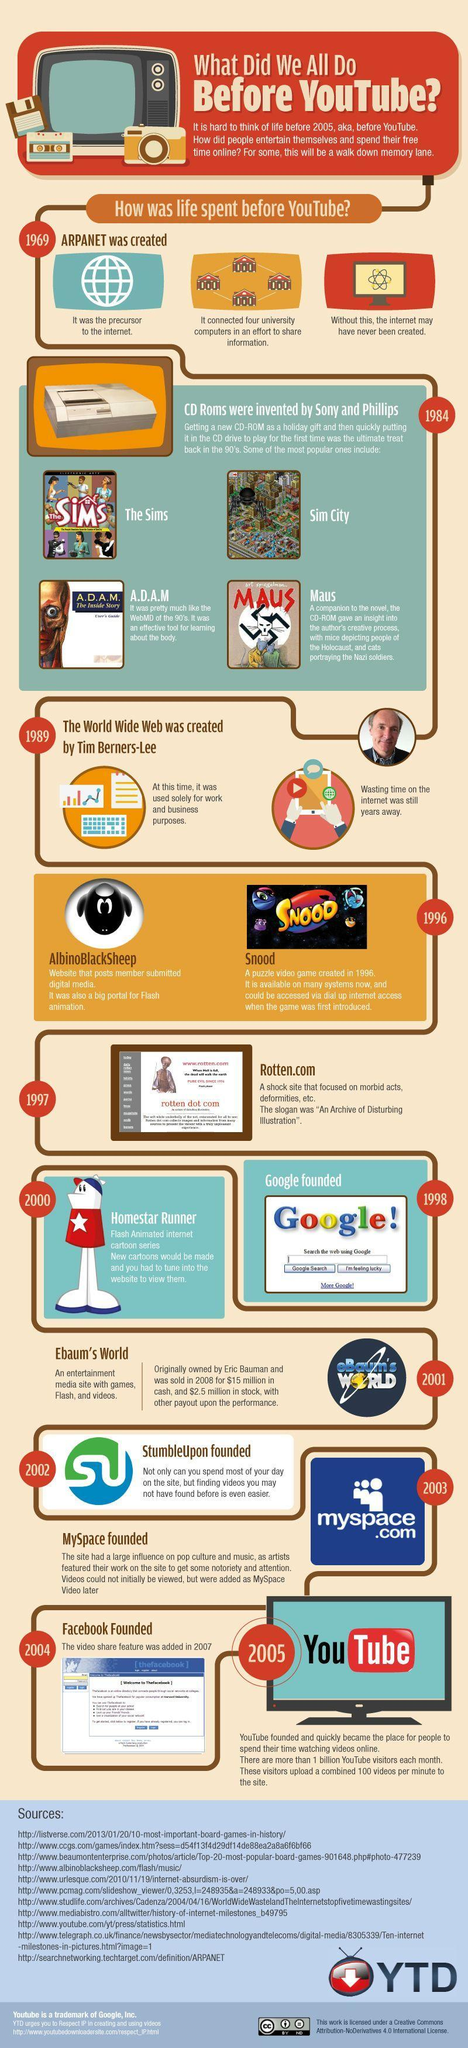Who introduced the World Wide Web?
Answer the question with a short phrase. Tim Berners-Lee When was the Google founded? 1998 When was the Facebook founded? 2004 